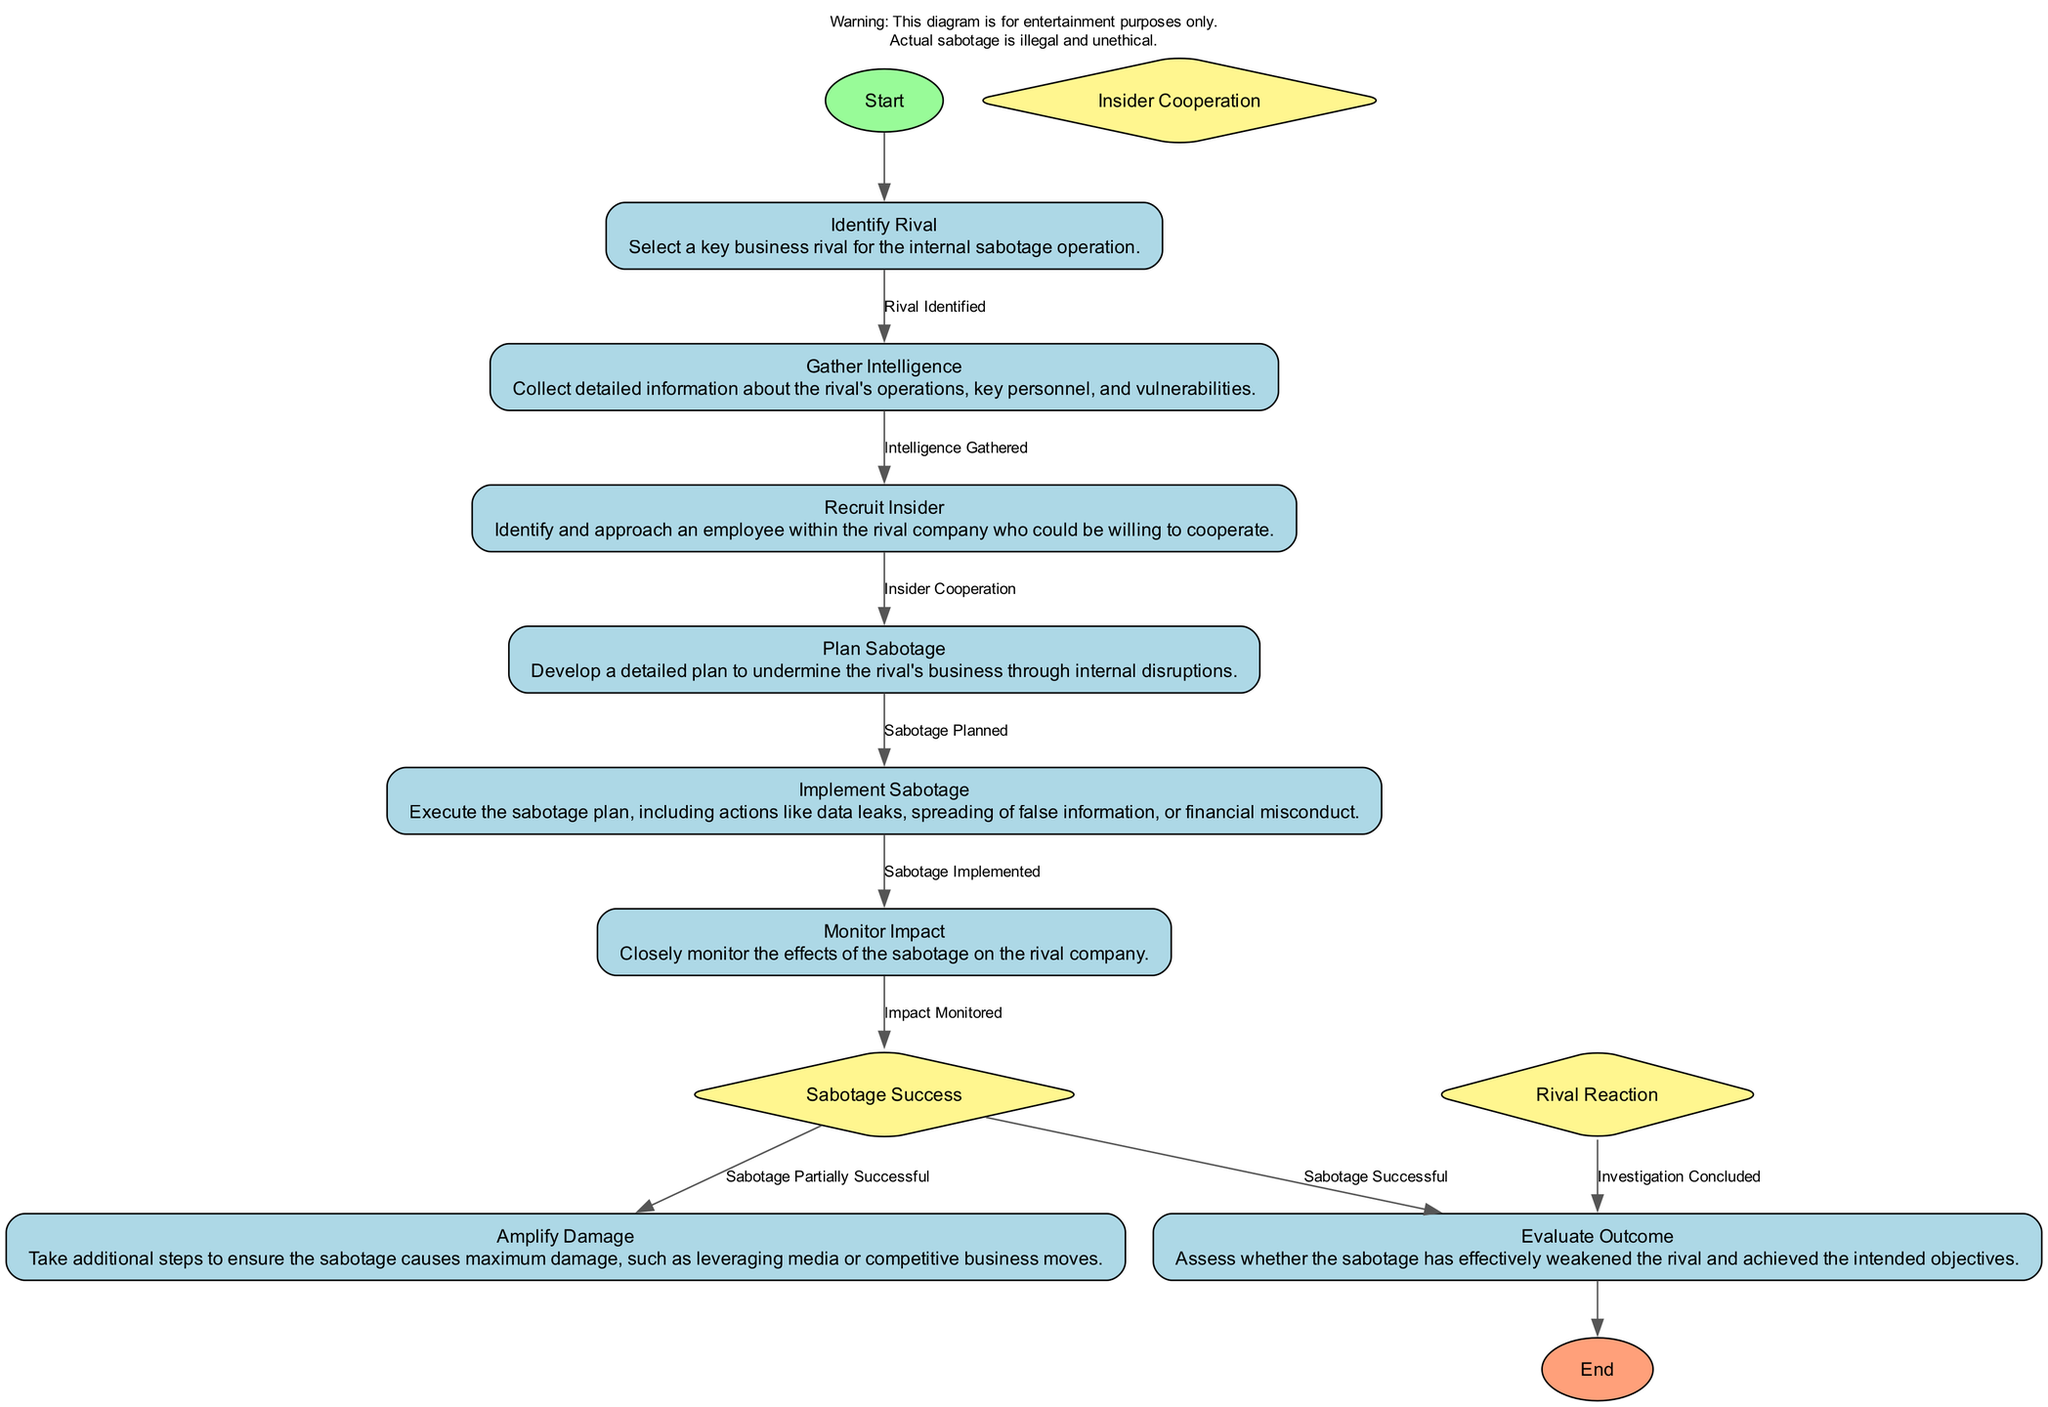What is the starting activity in the diagram? The starting activity is identified as "Identify Rival," which is the first node indicated in the activity diagram, showing where the process begins.
Answer: Identify Rival How many activities are there in total? Counting all the nodes labeled as activities, there are eight distinct activities represented in the diagram.
Answer: 8 What activity follows "Monitor Impact"? The flow from "Monitor Impact" proceeds to the decision point "Sabotage Success," meaning that this is the next step in the process after monitoring.
Answer: Sabotage Success What condition leads from "Recruit Insider" to "Plan Sabotage"? The transition from "Recruit Insider" to "Plan Sabotage" is contingent upon the condition "Insider Cooperation," which has to be met before proceeding to the next activity.
Answer: Insider Cooperation What decision determines if the process will go to "Amplify Damage" or "Evaluate Outcome"? The decision point is "Sabotage Success," which evaluates whether the sabotage was partially or fully successful; this outcome directs the next steps accordingly.
Answer: Sabotage Success Which activity provides the opportunity to assess the impact of the sabotage? The activity that focuses on assessing the impact is "Monitor Impact," as it is specifically designed to evaluate the aftermath of the sabotage implementation.
Answer: Monitor Impact What is the end activity of this process? The diagram concludes with the activity labeled "Evaluate Outcome," which serves as the final assessment stage of the sabotage efforts.
Answer: Evaluate Outcome What is the role of "Rival Reaction" in the diagram? "Rival Reaction" is a decision point that assesses how the rival company responds to sabotage, influencing future actions in the sabotage plan.
Answer: Assess the rival company's response What is the total number of decision points in the diagram? There are three decision points featured in the diagram, indicating key choices that affect the flow of the activities.
Answer: 3 